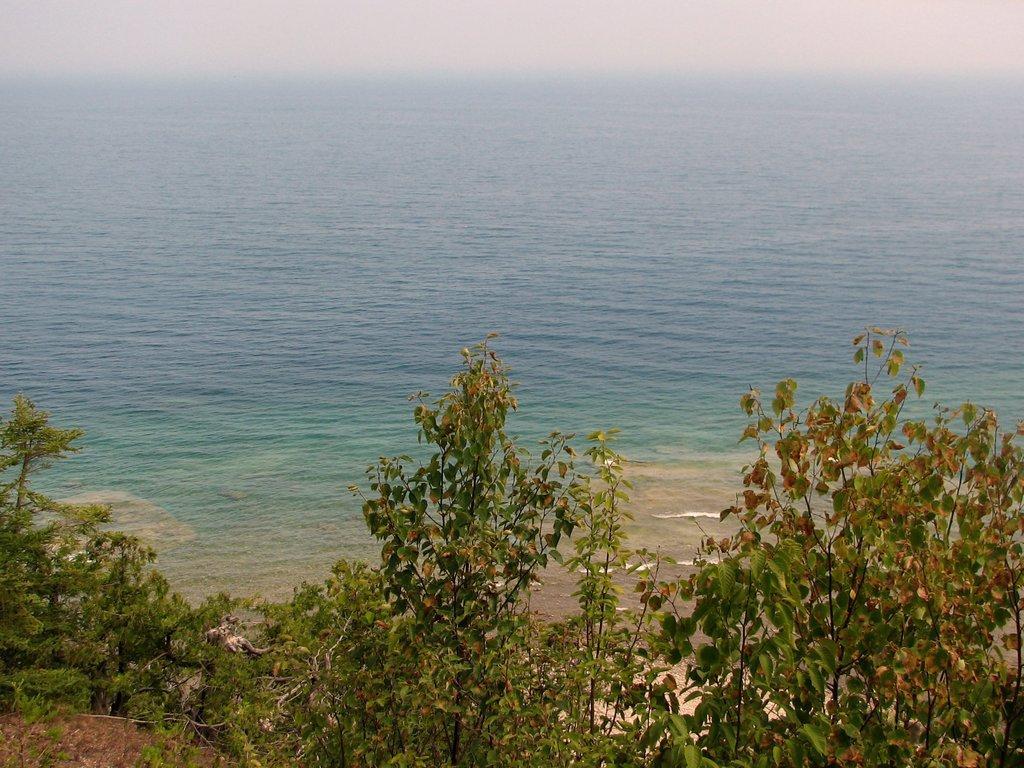How would you summarize this image in a sentence or two? There are trees on the hill near sand surface. Which is near the tides of the ocean. In the background, there are clouds in the sky. 